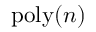Convert formula to latex. <formula><loc_0><loc_0><loc_500><loc_500>p o l y ( n )</formula> 